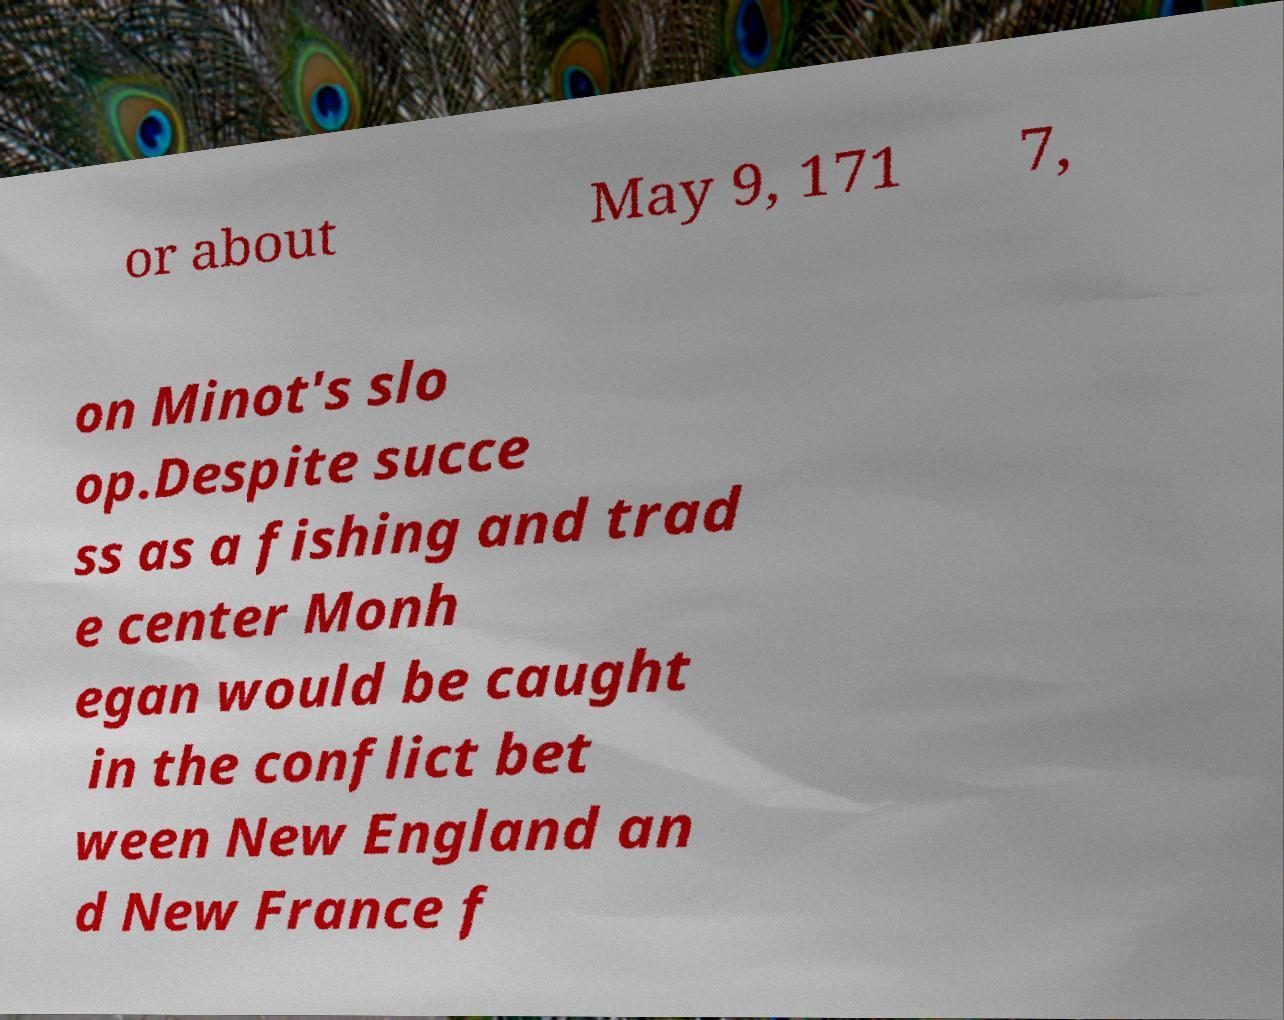Could you extract and type out the text from this image? or about May 9, 171 7, on Minot's slo op.Despite succe ss as a fishing and trad e center Monh egan would be caught in the conflict bet ween New England an d New France f 